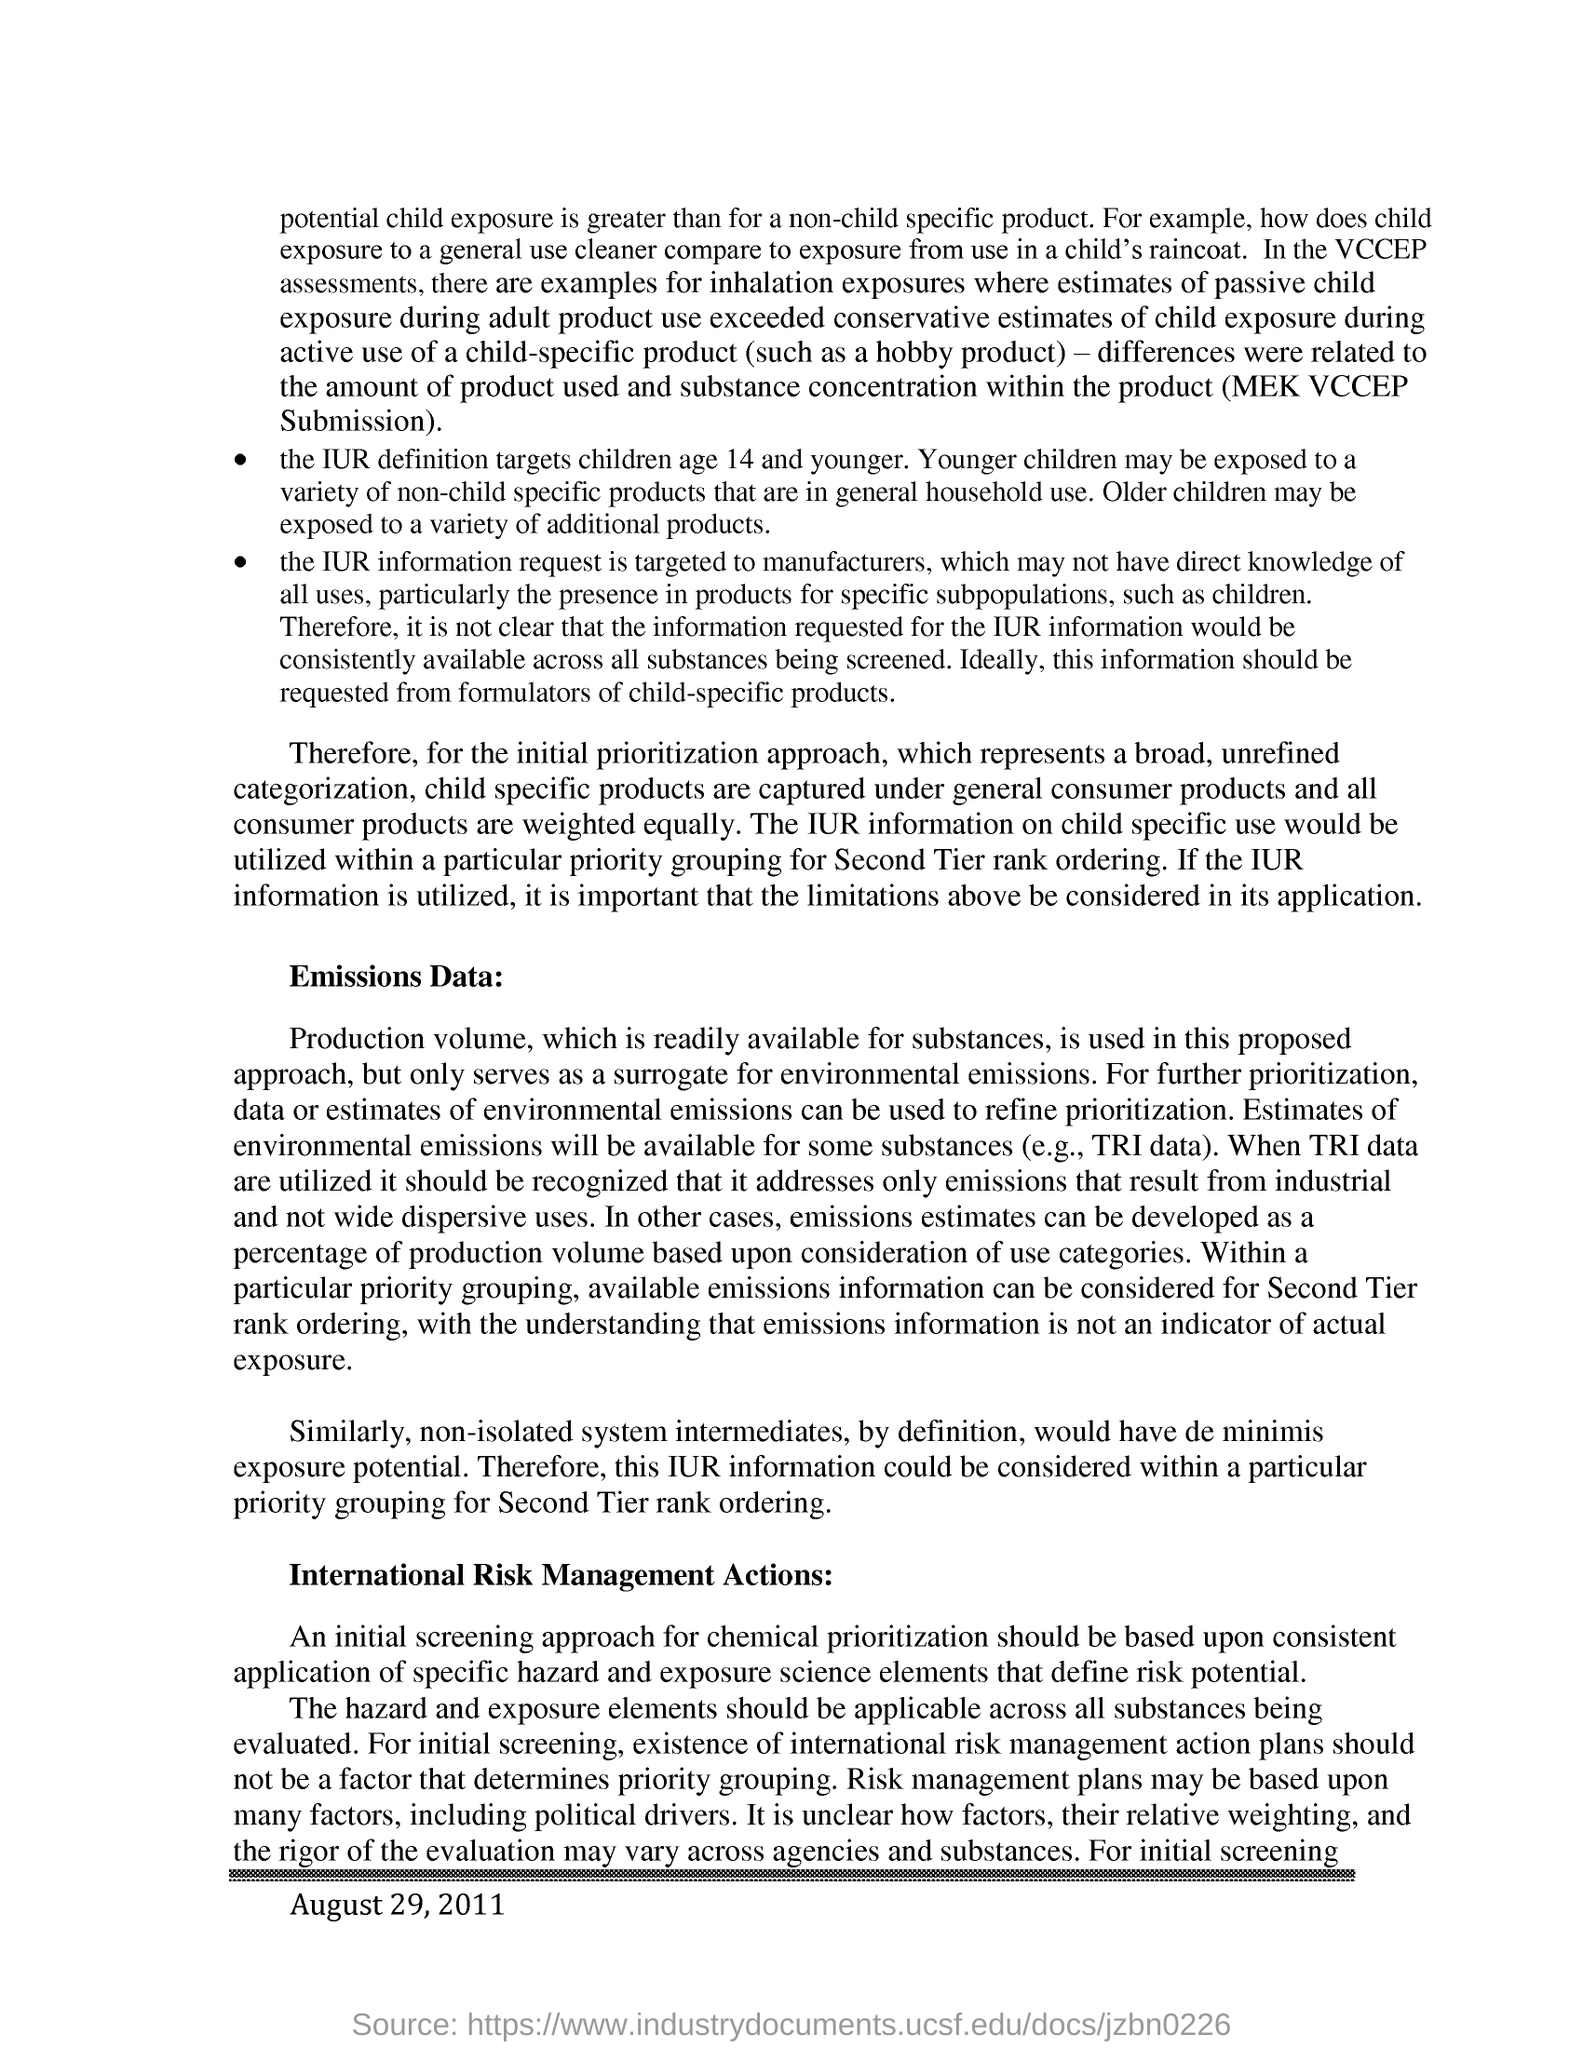Outline some significant characteristics in this image. The International Children's Digital Library definition targets children aged 14 and younger. The term "de minimis exposure potential" refers to the potential for exposure to a substance that is so small, it is considered insignificant. This can include non-isolated system intermediates, which are substances that exist in a system that is not completely isolated from the outside environment. In other words, non-isolated system intermediates have the potential to be exposed in small amounts, even if they are considered safe in isolation. It is necessary to consider IUR information within a particular priority grouping for second tier rank ordering as it provides a more comprehensive and nuanced understanding of the relative strengths and weaknesses of different types of evidence. Based on the consistent application of specific hazard and exposure science elements that define risk potential, an initial screening approach for chemical prioritization is done to prioritize the potential risks of chemicals. 